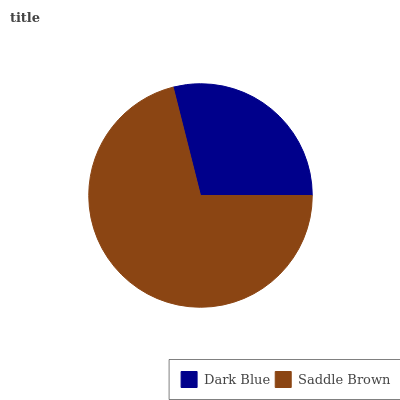Is Dark Blue the minimum?
Answer yes or no. Yes. Is Saddle Brown the maximum?
Answer yes or no. Yes. Is Saddle Brown the minimum?
Answer yes or no. No. Is Saddle Brown greater than Dark Blue?
Answer yes or no. Yes. Is Dark Blue less than Saddle Brown?
Answer yes or no. Yes. Is Dark Blue greater than Saddle Brown?
Answer yes or no. No. Is Saddle Brown less than Dark Blue?
Answer yes or no. No. Is Saddle Brown the high median?
Answer yes or no. Yes. Is Dark Blue the low median?
Answer yes or no. Yes. Is Dark Blue the high median?
Answer yes or no. No. Is Saddle Brown the low median?
Answer yes or no. No. 